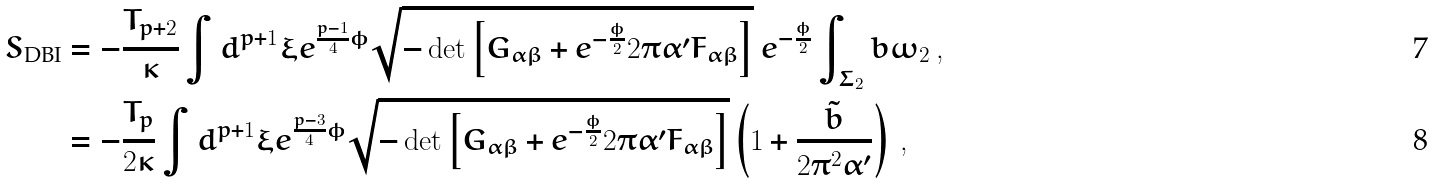Convert formula to latex. <formula><loc_0><loc_0><loc_500><loc_500>S _ { \text {DBI} } & = - \frac { T _ { p + 2 } } { \kappa } \int d ^ { p + 1 } \xi e ^ { \frac { p - 1 } { 4 } \phi } \sqrt { - \det \left [ G _ { \alpha \beta } + e ^ { - \frac { \phi } { 2 } } 2 \pi \alpha ^ { \prime } F _ { \alpha \beta } \right ] } \ e ^ { - \frac { \phi } { 2 } } \int _ { \Sigma _ { 2 } } b \omega _ { 2 } \, , \\ & = - \frac { T _ { p } } { 2 \kappa } \int d ^ { p + 1 } \xi e ^ { \frac { p - 3 } { 4 } \phi } \sqrt { - \det \left [ G _ { \alpha \beta } + e ^ { - \frac { \phi } { 2 } } 2 \pi \alpha ^ { \prime } F _ { \alpha \beta } \right ] } \left ( 1 + \frac { \tilde { b } } { 2 \pi ^ { 2 } \alpha ^ { \prime } } \right ) \, ,</formula> 